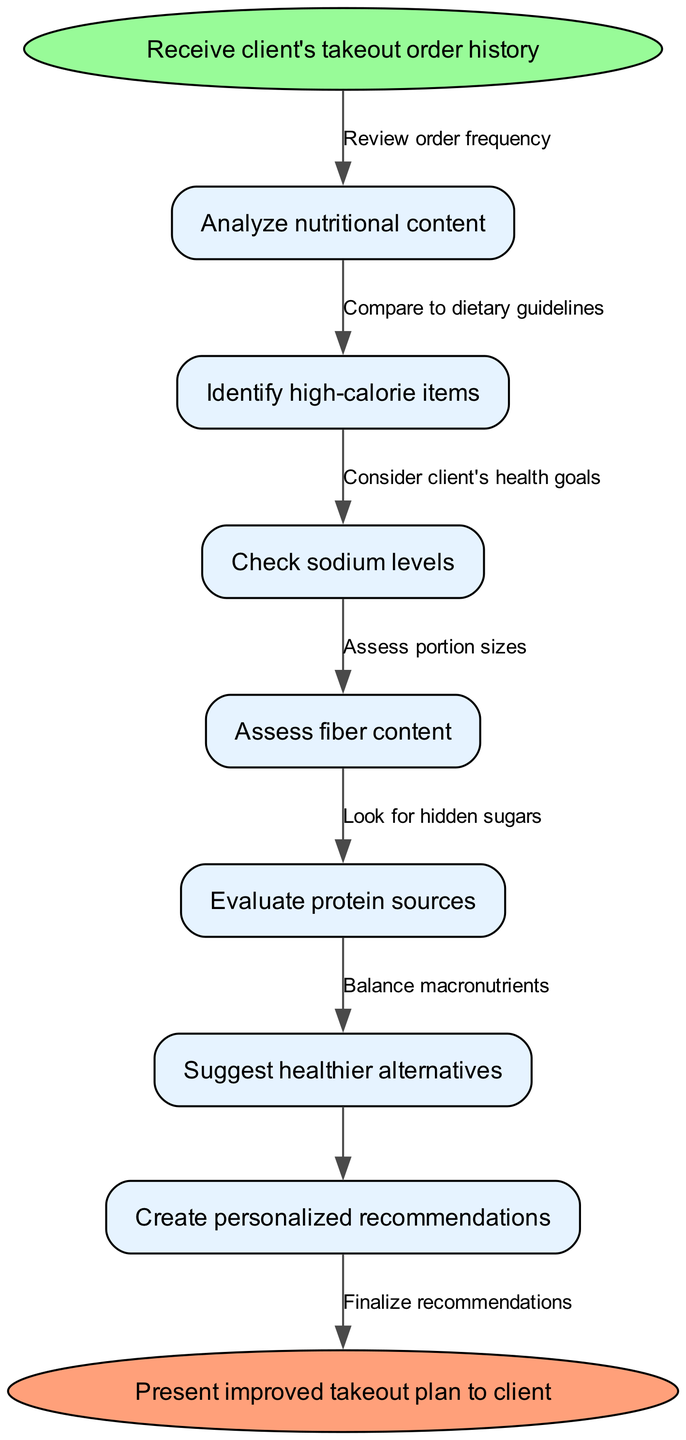What is the first step in the workflow? The first step is labeled as the start node, which indicates the initial action of "Receive client's takeout order history."
Answer: Receive client's takeout order history How many nodes are in the workflow? By counting the individual nodes in the diagram, including the start and end nodes, we find there are a total of 8 nodes.
Answer: 8 What is the output of the flowchart? The output is represented as the end node, which is "Present improved takeout plan to client."
Answer: Present improved takeout plan to client What is the last action before finalizing recommendations? The last action indicated before finalizing recommendations is "Evaluate protein sources."
Answer: Evaluate protein sources How many edges connect the nodes? There are 7 edges that connect the 8 nodes in the workflow, including connections from the start node and leading to the end node.
Answer: 7 What relationship exists between "Identify high-calorie items" and "Suggest healthier alternatives"? The relationship is that "Identify high-calorie items" is followed by the action of "Suggest healthier alternatives," indicating that recognizing less healthy items leads to proposing better options.
Answer: Suggest healthier alternatives Which node is connected to “Check sodium levels”? The node "Analyze nutritional content" is directly connected to "Check sodium levels," indicating it is the step that precedes checking sodium levels in the workflow.
Answer: Analyze nutritional content What is the goal of analyzing the nutritional content? The ultimate goal, as implied by the workflow, is to "Create personalized recommendations," which aligns with the objective of improving the client's takeout choices based on their dietary needs.
Answer: Create personalized recommendations 